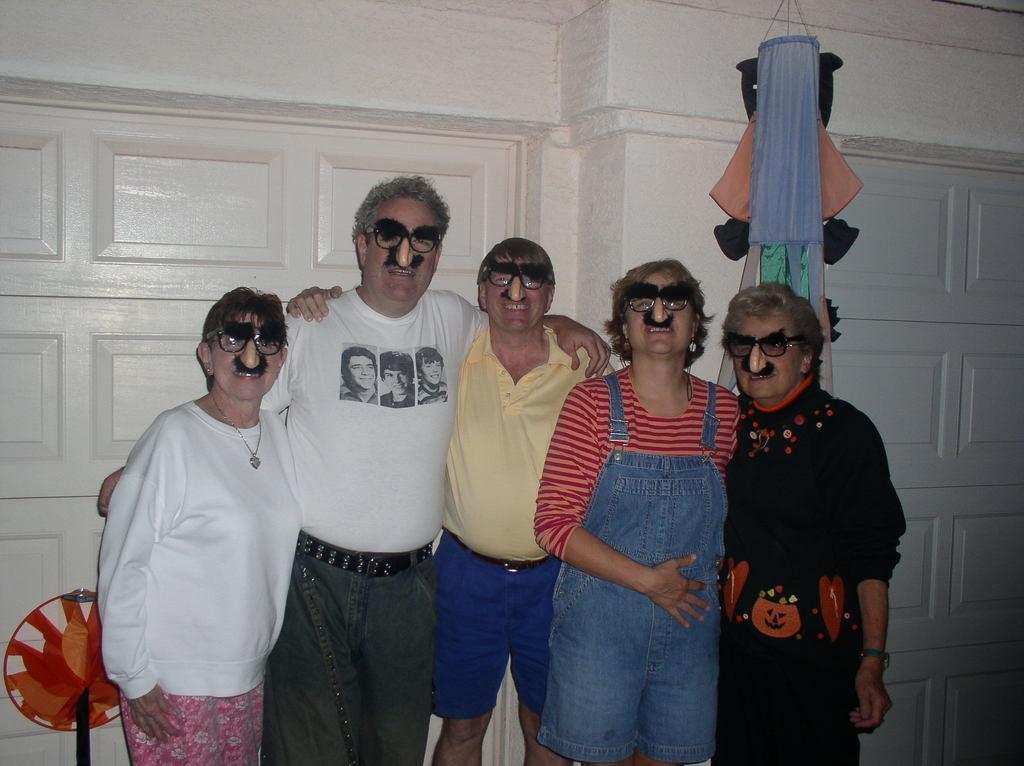How would you summarize this image in a sentence or two? In the picture I can see a group of people are standing together and wearing clothes and some other objects. In the background I can see a wall and some other objects. 